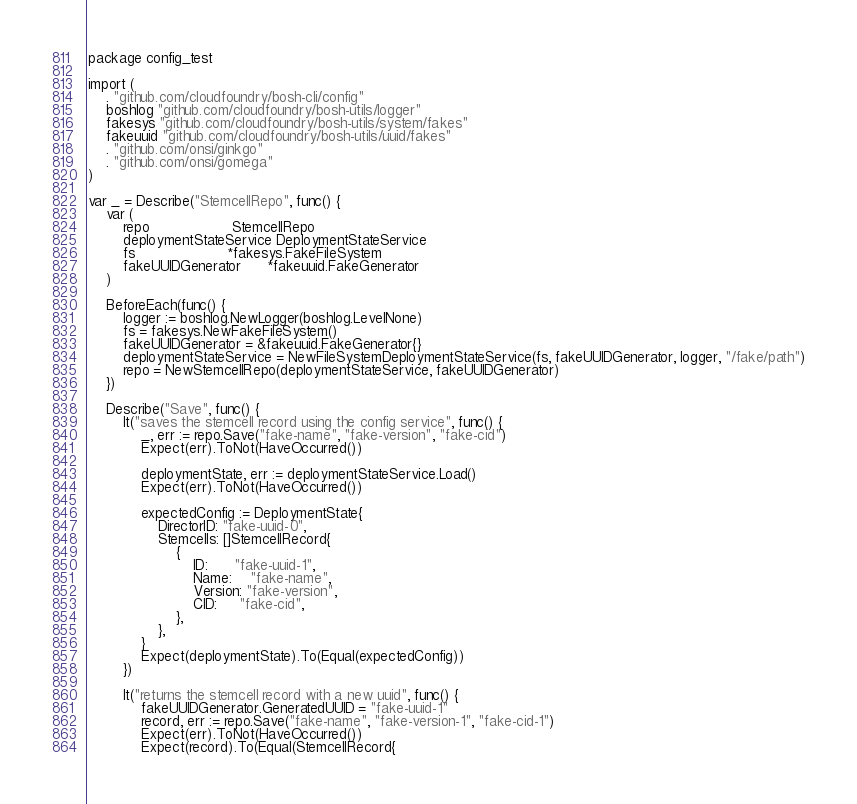<code> <loc_0><loc_0><loc_500><loc_500><_Go_>package config_test

import (
	. "github.com/cloudfoundry/bosh-cli/config"
	boshlog "github.com/cloudfoundry/bosh-utils/logger"
	fakesys "github.com/cloudfoundry/bosh-utils/system/fakes"
	fakeuuid "github.com/cloudfoundry/bosh-utils/uuid/fakes"
	. "github.com/onsi/ginkgo"
	. "github.com/onsi/gomega"
)

var _ = Describe("StemcellRepo", func() {
	var (
		repo                   StemcellRepo
		deploymentStateService DeploymentStateService
		fs                     *fakesys.FakeFileSystem
		fakeUUIDGenerator      *fakeuuid.FakeGenerator
	)

	BeforeEach(func() {
		logger := boshlog.NewLogger(boshlog.LevelNone)
		fs = fakesys.NewFakeFileSystem()
		fakeUUIDGenerator = &fakeuuid.FakeGenerator{}
		deploymentStateService = NewFileSystemDeploymentStateService(fs, fakeUUIDGenerator, logger, "/fake/path")
		repo = NewStemcellRepo(deploymentStateService, fakeUUIDGenerator)
	})

	Describe("Save", func() {
		It("saves the stemcell record using the config service", func() {
			_, err := repo.Save("fake-name", "fake-version", "fake-cid")
			Expect(err).ToNot(HaveOccurred())

			deploymentState, err := deploymentStateService.Load()
			Expect(err).ToNot(HaveOccurred())

			expectedConfig := DeploymentState{
				DirectorID: "fake-uuid-0",
				Stemcells: []StemcellRecord{
					{
						ID:      "fake-uuid-1",
						Name:    "fake-name",
						Version: "fake-version",
						CID:     "fake-cid",
					},
				},
			}
			Expect(deploymentState).To(Equal(expectedConfig))
		})

		It("returns the stemcell record with a new uuid", func() {
			fakeUUIDGenerator.GeneratedUUID = "fake-uuid-1"
			record, err := repo.Save("fake-name", "fake-version-1", "fake-cid-1")
			Expect(err).ToNot(HaveOccurred())
			Expect(record).To(Equal(StemcellRecord{</code> 